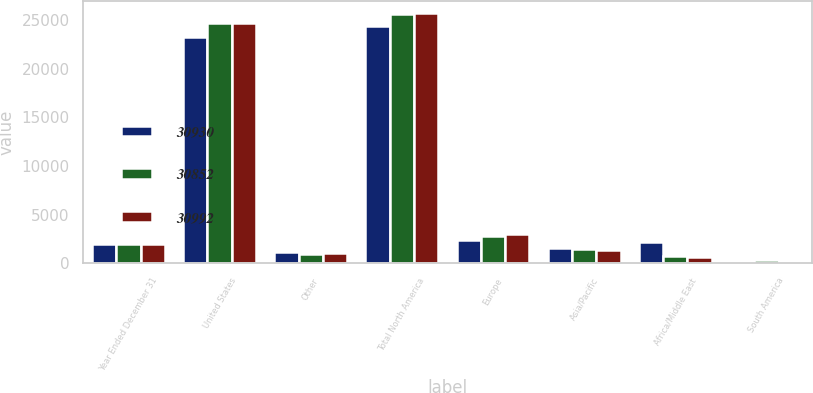Convert chart to OTSL. <chart><loc_0><loc_0><loc_500><loc_500><stacked_bar_chart><ecel><fcel>Year Ended December 31<fcel>United States<fcel>Other<fcel>Total North America<fcel>Europe<fcel>Asia/Pacific<fcel>Africa/Middle East<fcel>South America<nl><fcel>30930<fcel>2014<fcel>23222<fcel>1174<fcel>24396<fcel>2410<fcel>1608<fcel>2163<fcel>275<nl><fcel>30852<fcel>2013<fcel>24646<fcel>959<fcel>25605<fcel>2795<fcel>1466<fcel>736<fcel>328<nl><fcel>30992<fcel>2012<fcel>24636<fcel>1035<fcel>25671<fcel>3013<fcel>1405<fcel>689<fcel>214<nl></chart> 